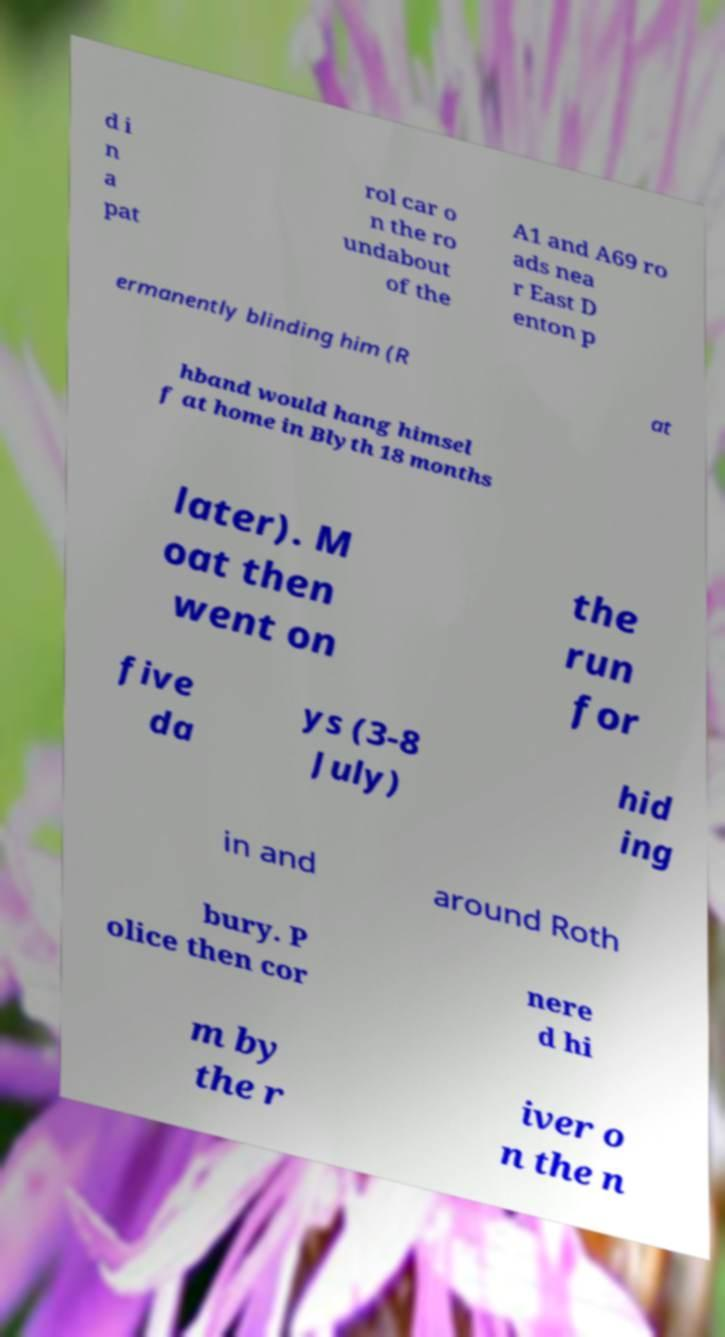Please identify and transcribe the text found in this image. d i n a pat rol car o n the ro undabout of the A1 and A69 ro ads nea r East D enton p ermanently blinding him (R at hband would hang himsel f at home in Blyth 18 months later). M oat then went on the run for five da ys (3-8 July) hid ing in and around Roth bury. P olice then cor nere d hi m by the r iver o n the n 